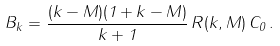<formula> <loc_0><loc_0><loc_500><loc_500>B _ { k } = \frac { ( k - M ) ( 1 + k - M ) } { k + 1 } \, R ( k , M ) \, C _ { 0 } \, .</formula> 